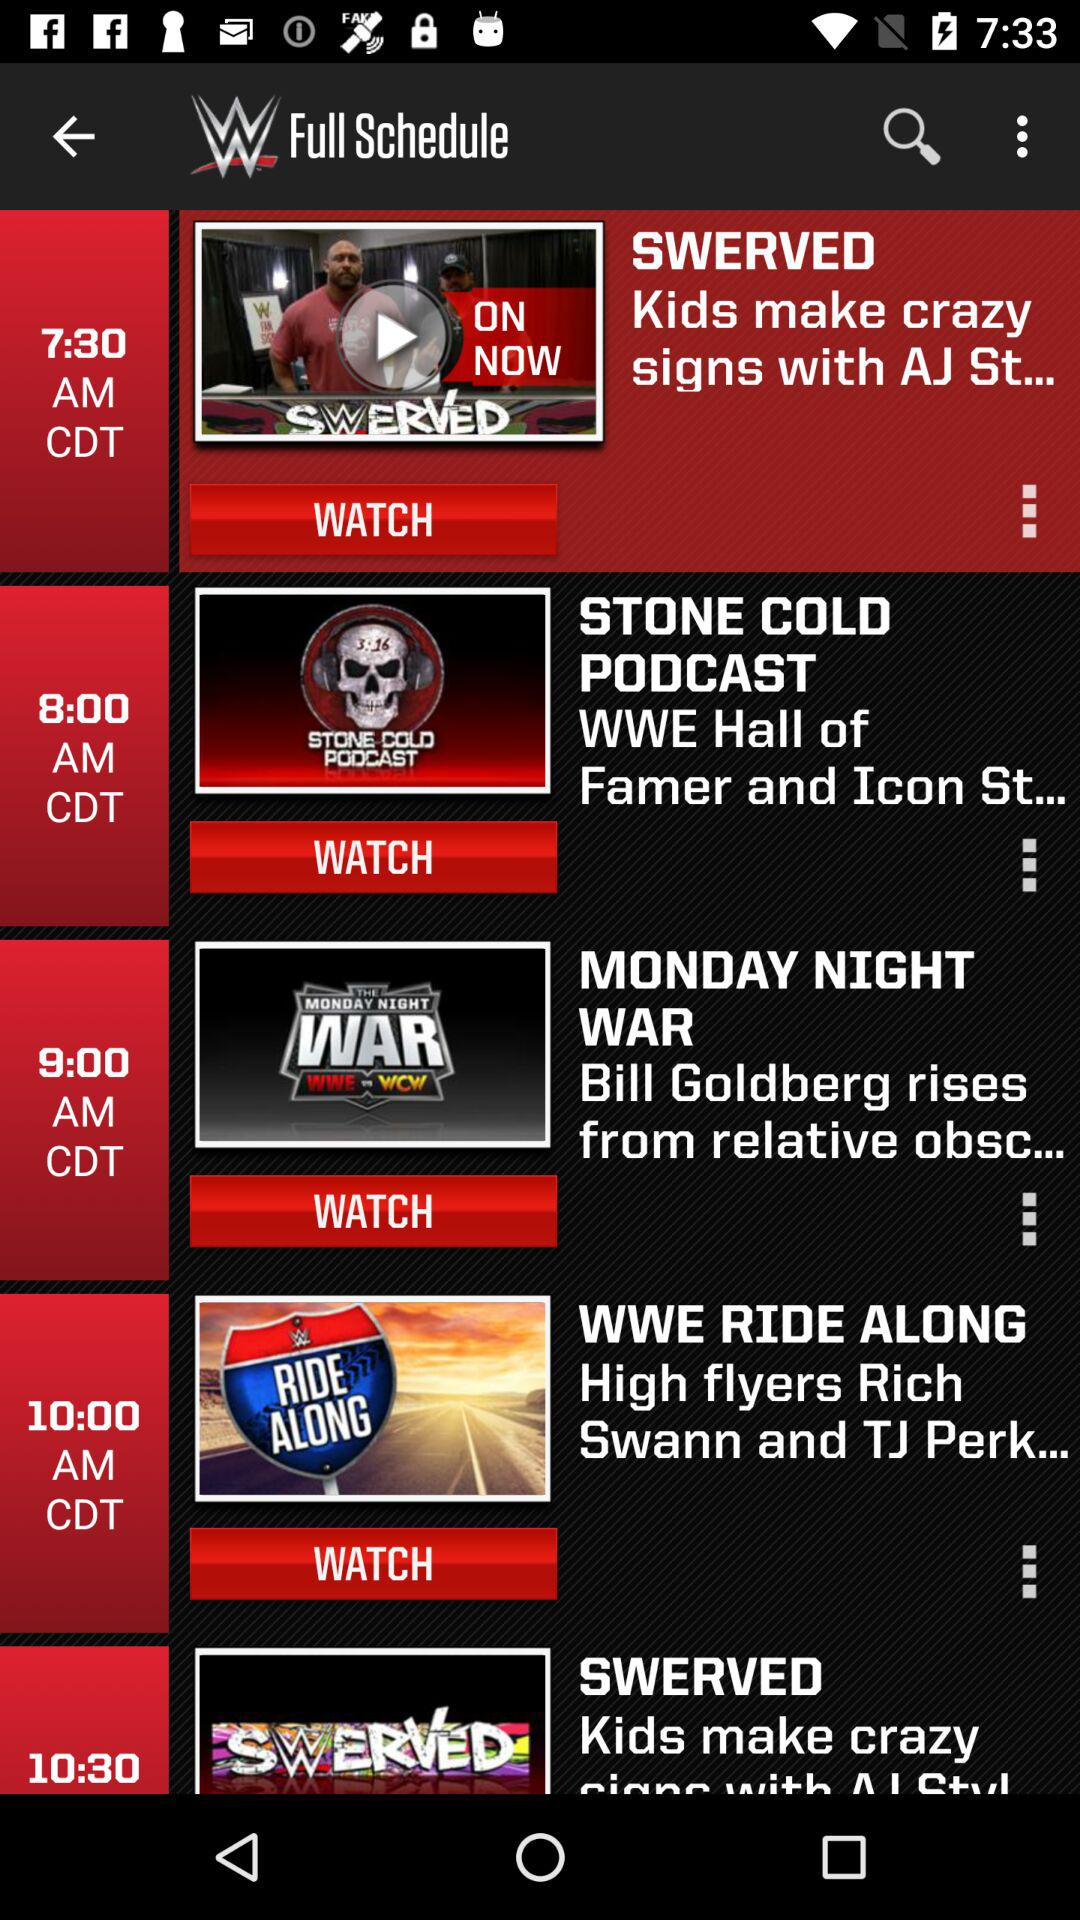What is scheduled to air at 7:30 a.m.? Scheduled to air at 7:30 a.m. is "SWERVED". 